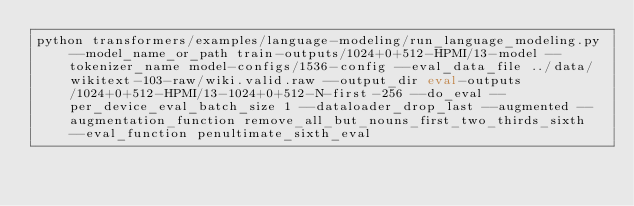<code> <loc_0><loc_0><loc_500><loc_500><_Bash_>python transformers/examples/language-modeling/run_language_modeling.py --model_name_or_path train-outputs/1024+0+512-HPMI/13-model --tokenizer_name model-configs/1536-config --eval_data_file ../data/wikitext-103-raw/wiki.valid.raw --output_dir eval-outputs/1024+0+512-HPMI/13-1024+0+512-N-first-256 --do_eval --per_device_eval_batch_size 1 --dataloader_drop_last --augmented --augmentation_function remove_all_but_nouns_first_two_thirds_sixth --eval_function penultimate_sixth_eval</code> 